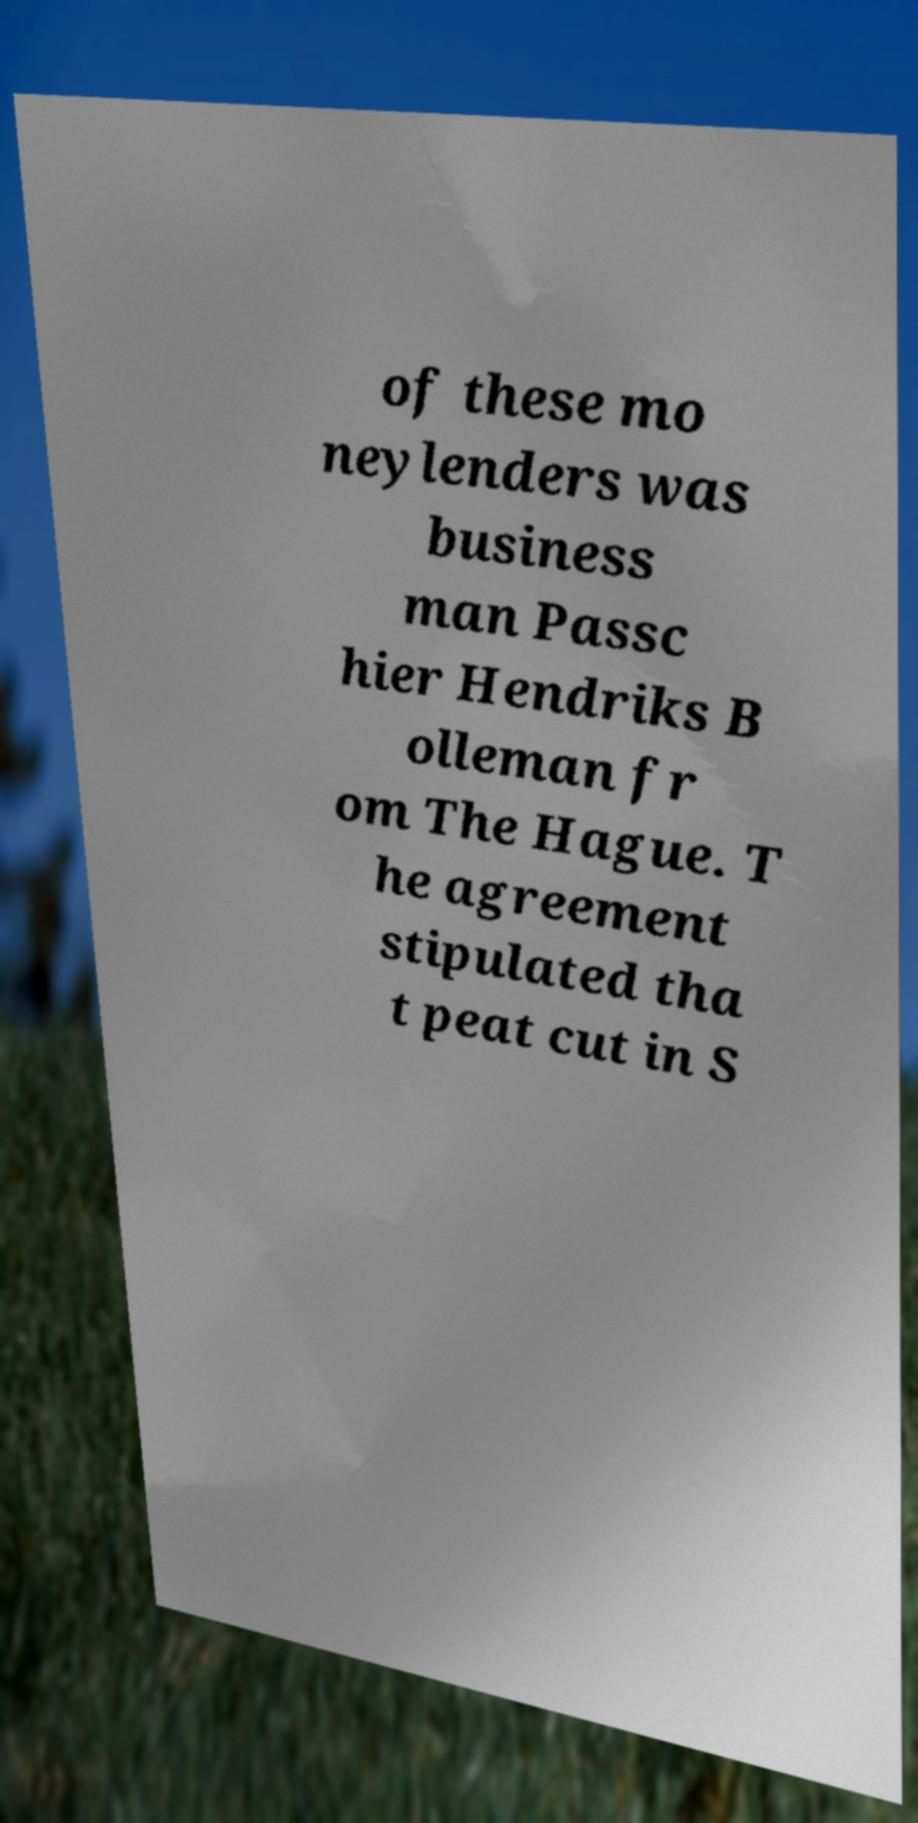There's text embedded in this image that I need extracted. Can you transcribe it verbatim? of these mo neylenders was business man Passc hier Hendriks B olleman fr om The Hague. T he agreement stipulated tha t peat cut in S 